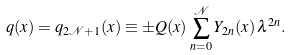<formula> <loc_0><loc_0><loc_500><loc_500>q ( x ) = q _ { 2 \mathcal { N } + 1 } ( x ) \equiv \pm Q ( x ) \, \sum _ { n = 0 } ^ { \mathcal { N } } Y _ { 2 n } ( x ) \, \lambda ^ { 2 n } .</formula> 